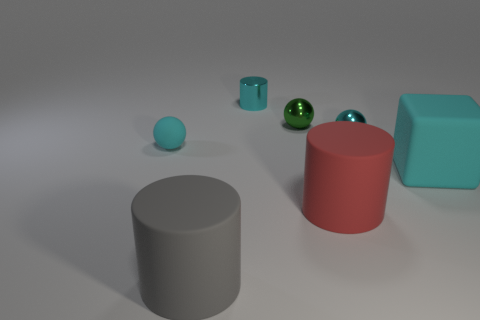Add 1 small blue rubber cylinders. How many objects exist? 8 Subtract all tiny metal spheres. How many spheres are left? 1 Subtract all cyan cylinders. How many brown cubes are left? 0 Subtract all green spheres. How many spheres are left? 2 Subtract 1 gray cylinders. How many objects are left? 6 Subtract all balls. How many objects are left? 4 Subtract 2 cylinders. How many cylinders are left? 1 Subtract all red blocks. Subtract all cyan spheres. How many blocks are left? 1 Subtract all big green blocks. Subtract all red cylinders. How many objects are left? 6 Add 6 shiny objects. How many shiny objects are left? 9 